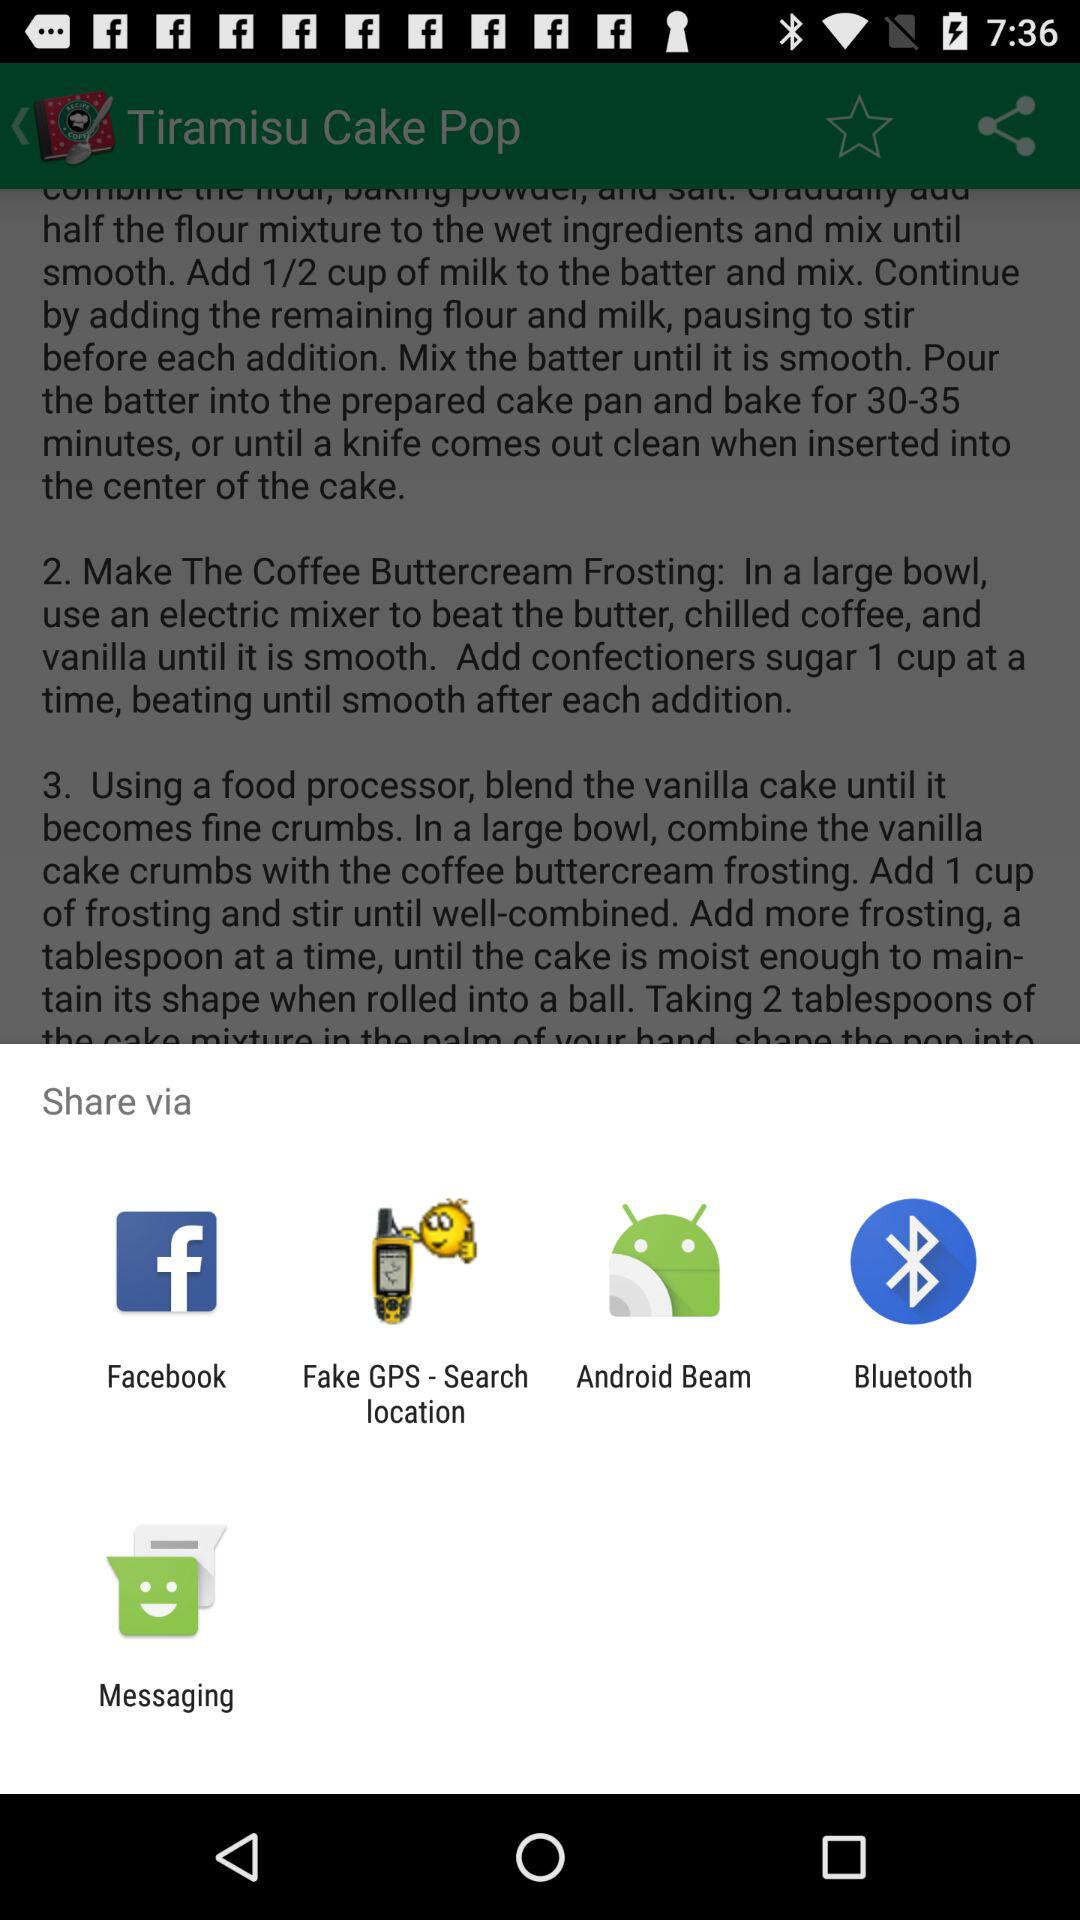What are the sharing options available? The sharing options are "Facebook", "Fake GPS - Search location", "Android Beam", "Bluetooth" and "Messaging". 